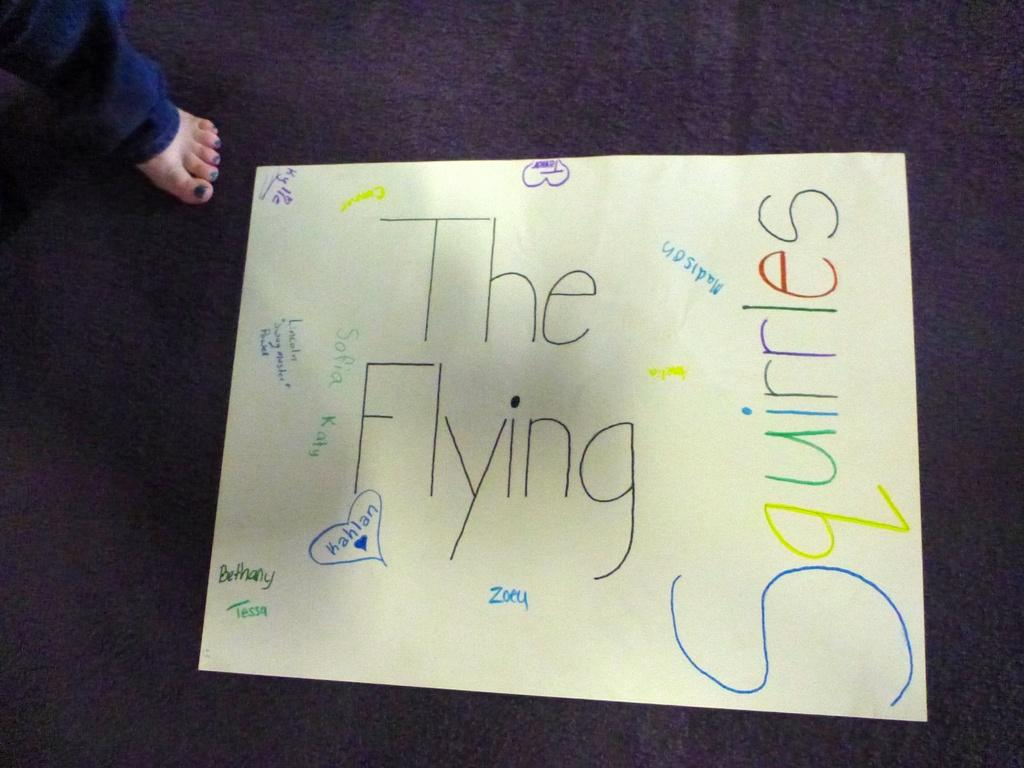What is written on the sheet in the image? The sheet in the image contains text. What part of a person can be seen in the image? A human leg is visible in the image. What color is the background of the image? The background of the image is blue. What type of organization is represented by the flower in the image? There is no flower present in the image, so it is not possible to determine what type of organization it might represent. 